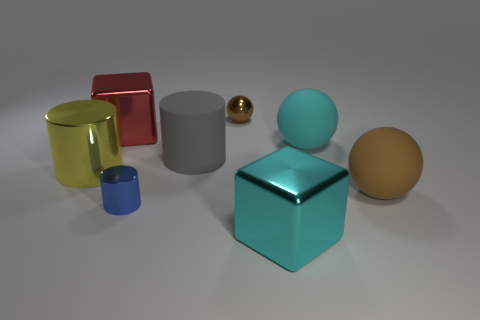Compare the size of the red cube with the other objects in the image. The red cube is mid-sized compared to the other objects. It is larger than both spheres, the small blue cube, and the small yellow cylinder but smaller than the large gray cylinder and the teal cube, which is the largest object in the scene. 